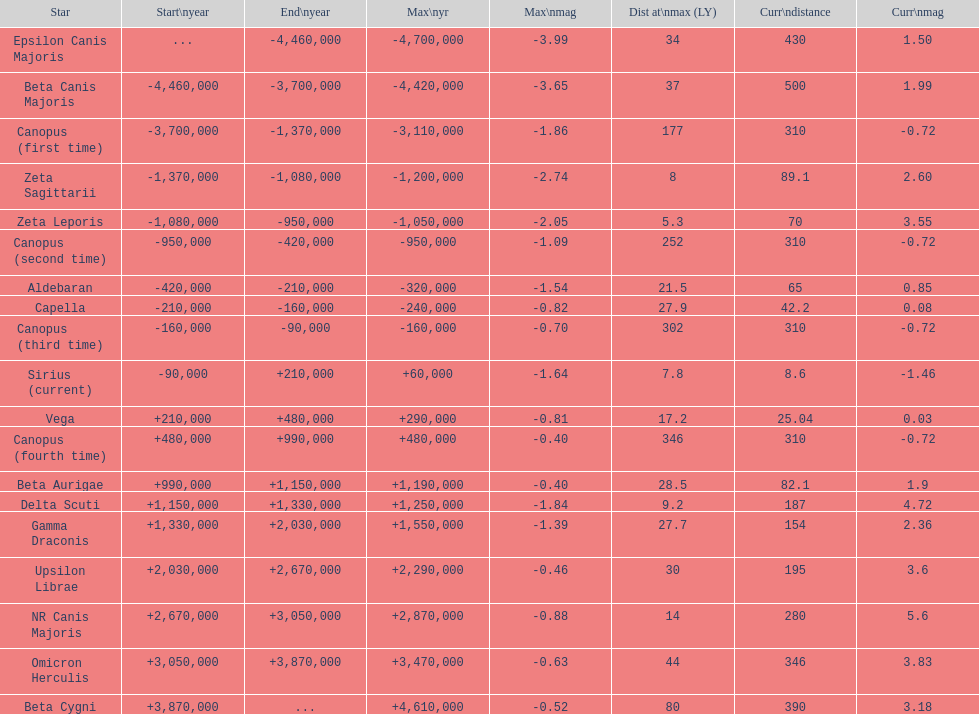What is the only star with a distance at maximum of 80? Beta Cygni. 